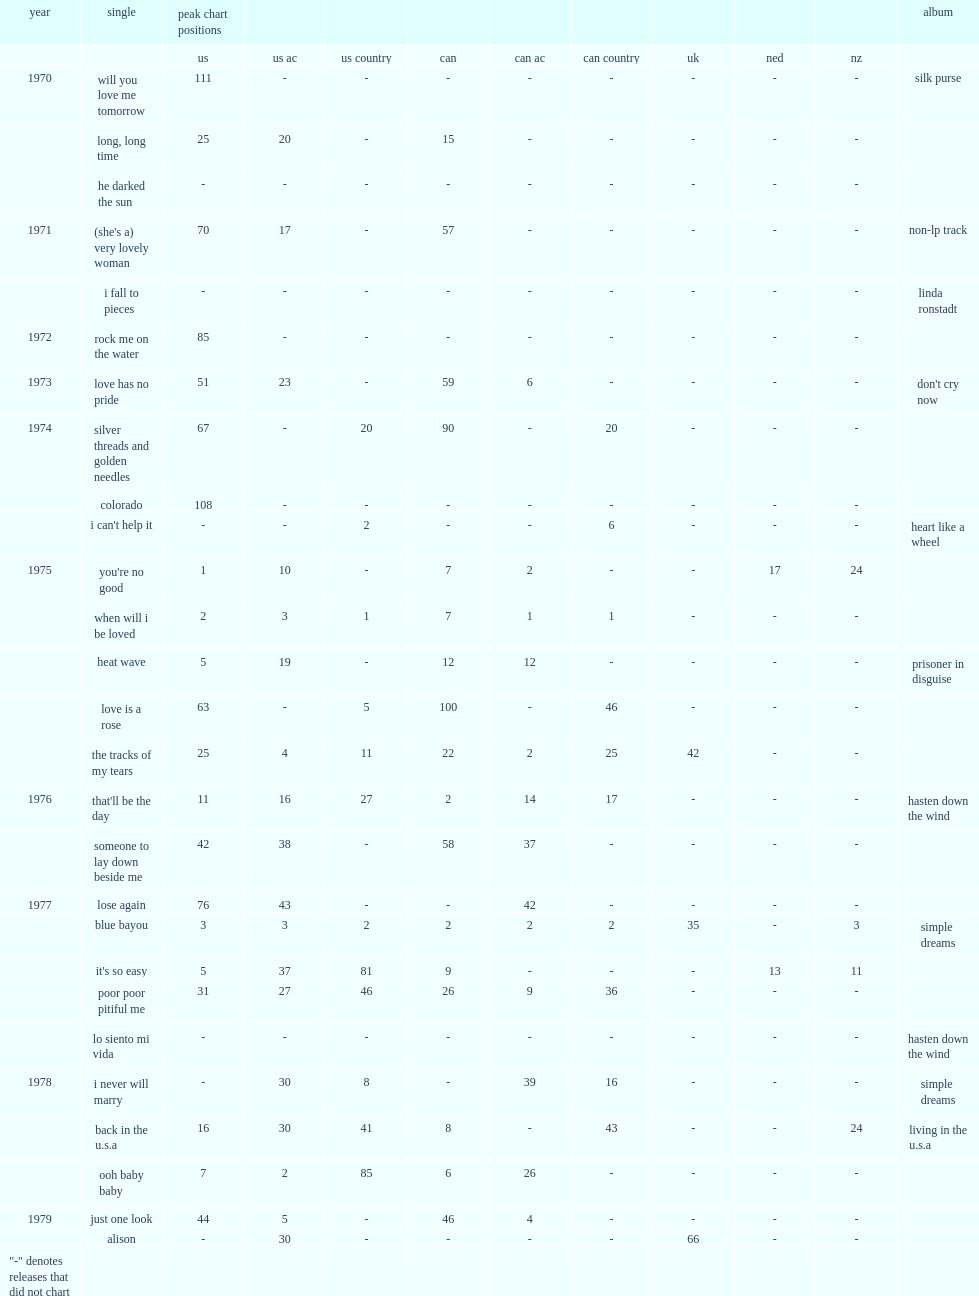In 1975, which linda ronstadt's album contained the single "heat wave"? Prisoner in disguise. 